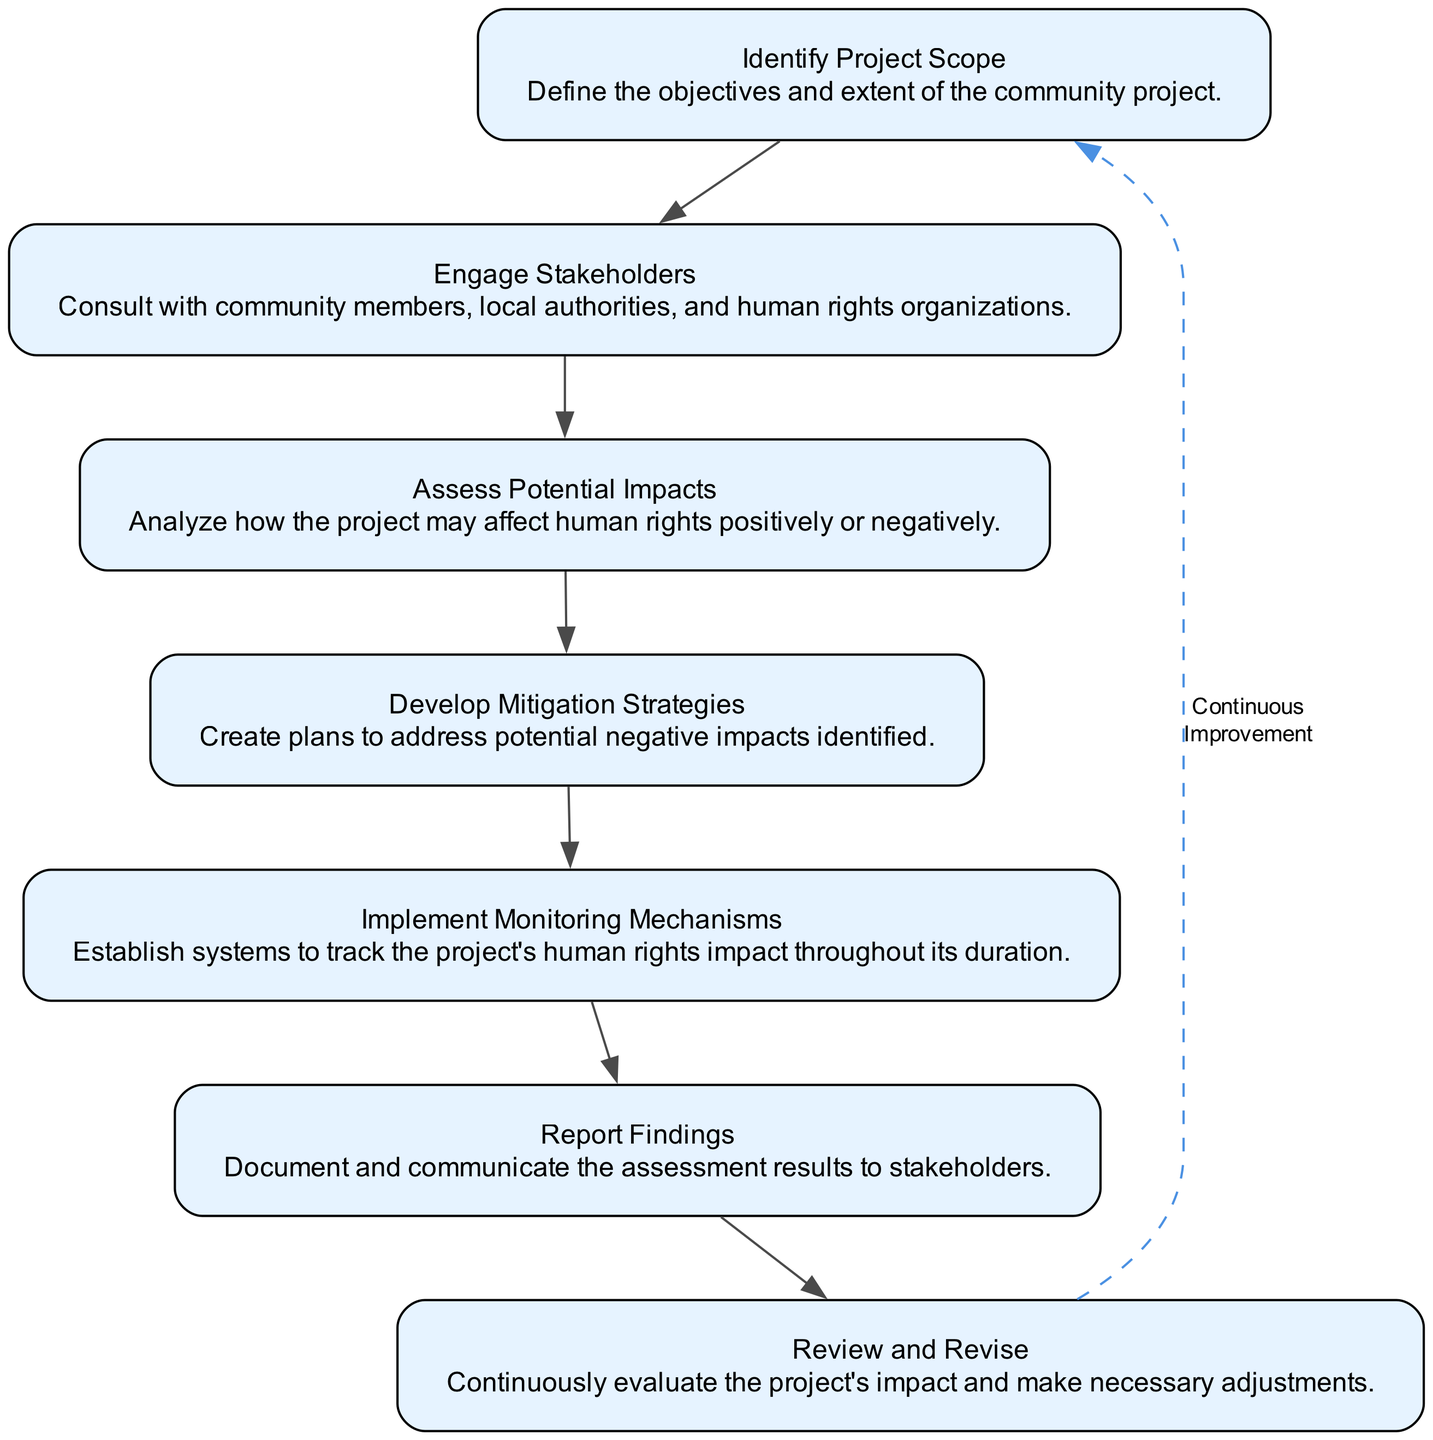What is the first step in the human rights impact assessment? The first step in the assessment, as indicated in the diagram, is "Identify Project Scope." This step lays the foundation for the entire process by defining what the project aims to achieve and its overall extent.
Answer: Identify Project Scope How many total steps are represented in the diagram? By counting each distinct step listed in the diagram, we find that there are seven steps in total. Each step is crucial for conducting a thorough assessment.
Answer: 7 What does the "Engage Stakeholders" step involve? The description states that "Engage Stakeholders" involves consulting with community members, local authorities, and human rights organizations. This ensures diverse perspectives are considered in the assessment process.
Answer: Consult with community members, local authorities, and human rights organizations Which step follows "Assess Potential Impacts"? The next step after "Assess Potential Impacts" is "Develop Mitigation Strategies." This indicates that after understanding the possible impacts, plans are needed to address any negative effects identified.
Answer: Develop Mitigation Strategies What does the last node in the diagram emphasize? The last node highlights the importance of "Review and Revise," indicating it is a crucial part for continuous improvement. It suggests that the assessment process should not be static but adaptable.
Answer: Continuous Improvement Which step involves tracking the project's human rights impact? The step that involves tracking the impacts of the project is "Implement Monitoring Mechanisms." This is essential for ongoing oversight throughout the project's life to ensure compliance with human rights standards.
Answer: Implement Monitoring Mechanisms How does the flow of the diagram suggest continuous improvement? The flow indicates that after "Review and Revise," there is a dashed edge connecting back to "Identify Project Scope." This implies that the assessment is a cyclical process, where continuous feedback leads to refining the project's scope.
Answer: Continuous Improvement What is the purpose of the "Report Findings" step? The "Report Findings" step serves the purpose of documenting and communicating the assessment results to stakeholders, ensuring transparency and accountability in the process.
Answer: Document and communicate the assessment results to stakeholders 